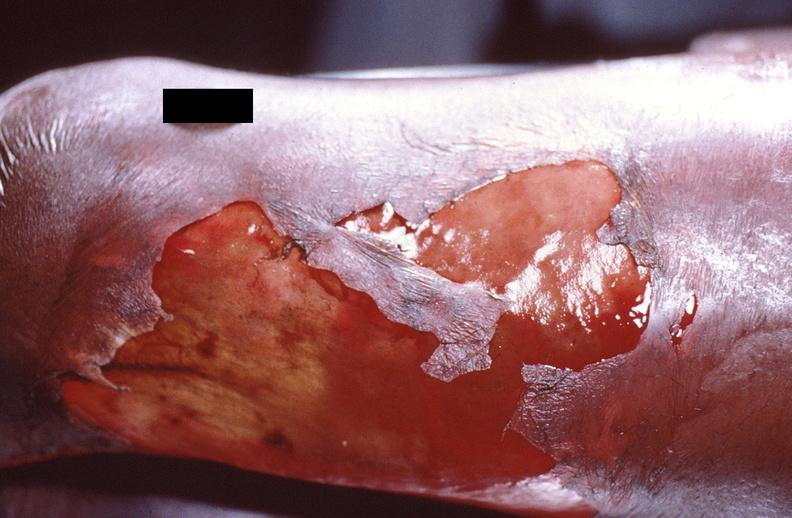where is this?
Answer the question using a single word or phrase. Skin 